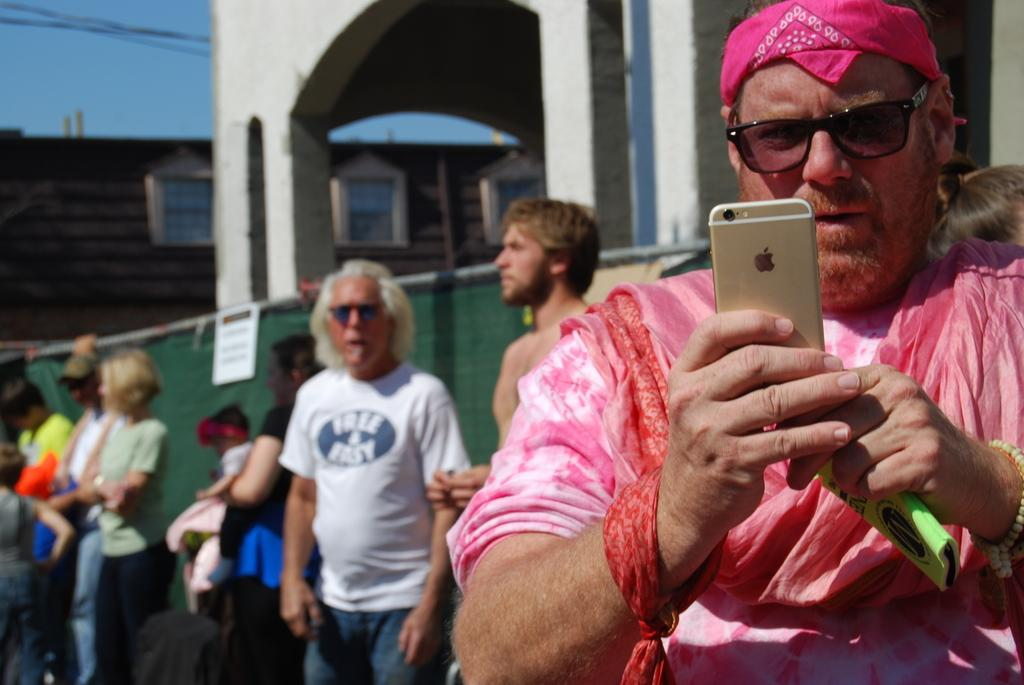What is the man in the image doing? The man is standing in the image and holding a phone. Are there any other people in the image? Yes, there are people standing together in the image. Where are the people located in relation to the building? The people are beside a building. What type of disease is being protested against in the image? There is no protest or mention of a disease in the image; it simply shows a man holding a phone and people standing together beside a building. 